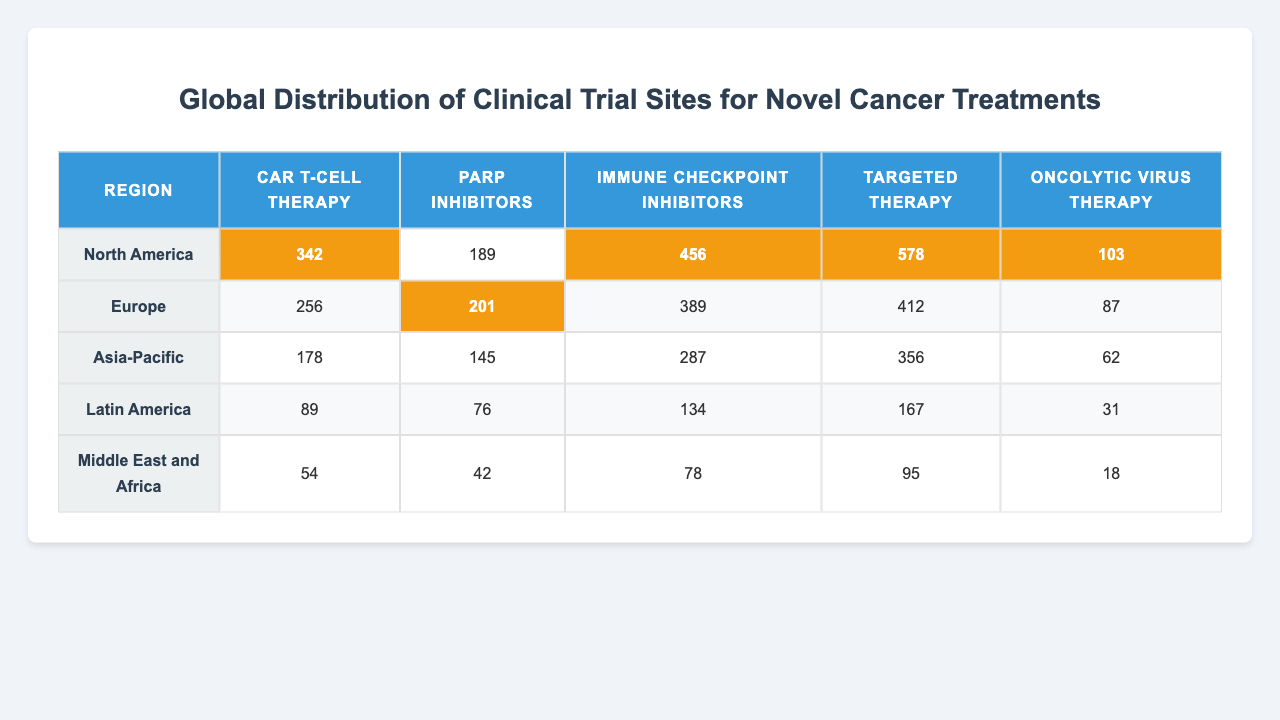What region has the highest number of clinical trial sites for CAR T-cell therapy? The table shows that North America has the highest number of clinical trial sites for CAR T-cell therapy with 342 sites compared to other regions.
Answer: North America Which cancer treatment has the lowest number of clinical trial sites in Europe? In the European region, the treatment with the lowest number of clinical trial sites is Oncolytic virus therapy, which has 87 sites.
Answer: Oncolytic virus therapy What is the total number of clinical trial sites for Immunotherapy across all regions? To find the total, we add the number of sites for Immunotherapy (Immune checkpoint inhibitors): North America (456) + Europe (389) + Asia-Pacific (287) + Latin America (134) + Middle East and Africa (78) = 1344.
Answer: 1344 Is the number of trial sites for PARP inhibitors higher in Asia-Pacific than in Latin America? The table shows that Asia-Pacific has 145 sites for PARP inhibitors while Latin America has 76, which means Asia-Pacific has more sites.
Answer: Yes Calculate the average number of clinical trial sites for Targeted therapy across all regions. To find the average, we sum the number of sites for Targeted therapy: 578 (North America) + 412 (Europe) + 356 (Asia-Pacific) + 167 (Latin America) + 95 (Middle East and Africa) = 1708. With 5 regions, the average is 1708/5 = 341.6.
Answer: 341.6 Which region has the highest total number of clinical trial sites across all treatments? By summing the number of sites across all treatments for each region, we get: North America (342 + 189 + 456 + 578 + 103 = 1678), Europe (256 + 201 + 389 + 412 + 87 = 1345), Asia-Pacific (178 + 145 + 287 + 356 + 62 = 1028), Latin America (89 + 76 + 134 + 167 + 31 = 497), and Middle East and Africa (54 + 42 + 78 + 95 + 18 = 287). North America has the highest total with 1678 sites.
Answer: North America In which treatment category does the Middle East and Africa have the smallest number of clinical trial sites? The table shows that the Middle East and Africa has the smallest number of clinical trial sites in Oncolytic virus therapy with only 18 sites.
Answer: Oncolytic virus therapy Is the number of clinical trial sites for Immune checkpoint inhibitors in North America greater or less than the combined total of the same treatment in Latin America and Middle East and Africa? For Immune checkpoint inhibitors, North America has 456 sites, while Latin America has 134 and Middle East and Africa has 78, totaling 212. Since 456 is greater than 212, North America has more sites.
Answer: Greater What is the total number of clinical trial sites for Oncolytic virus therapy across all regions? To find the total, we sum the number of sites for Oncolytic virus therapy: 103 (North America) + 87 (Europe) + 62 (Asia-Pacific) + 31 (Latin America) + 18 (Middle East and Africa) = 301.
Answer: 301 Which cancer treatment has the most significant difference in number of clinical trial sites between North America and the Middle East and Africa? Comparing the number of sites: CAR T-cell therapy (342 vs 54 = 288), PARP inhibitors (189 vs 42 = 147), Immune checkpoint inhibitors (456 vs 78 = 378), Targeted therapy (578 vs 95 = 483), and Oncolytic virus therapy (103 vs 18 = 85). The largest difference is for Targeted therapy with 483 sites.
Answer: Targeted therapy 